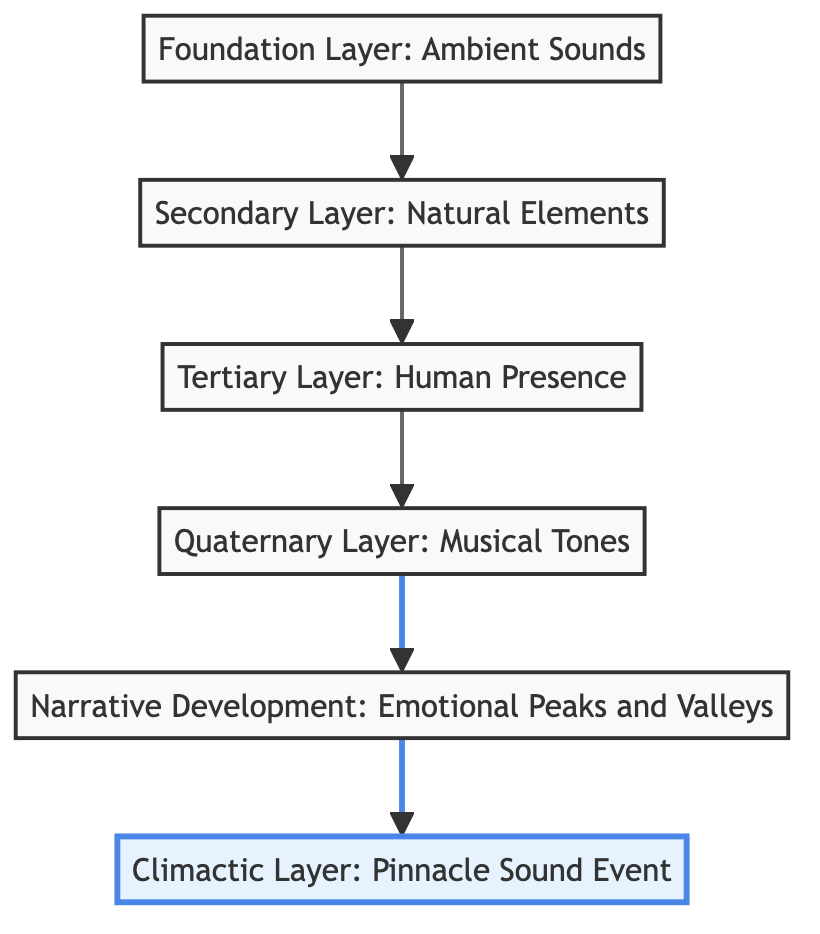What is the highest layer in the flow chart? The highest layer in the flow chart is the "Climactic Layer: Pinnacle Sound Event," which is positioned at the top and highlighted.
Answer: Climactic Layer: Pinnacle Sound Event How many layers are in the diagram? There are a total of six layers depicted in the flow chart, starting from the "Foundation Layer: Ambient Sounds" to the "Climactic Layer: Pinnacle Sound Event."
Answer: Six What comes directly before the "Narrative Development: Emotional Peaks and Valleys"? The layer that comes directly before the "Narrative Development: Emotional Peaks and Valleys" is the "Quaternary Layer: Musical Tones," which flows into the Narrative Development node.
Answer: Quaternary Layer: Musical Tones What is the role of the "Tertiary Layer: Human Presence"? The "Tertiary Layer: Human Presence" serves to introduce subtle indications of human presence to the soundscape, adding complexity and depth between the "Secondary Layer: Natural Elements" and the "Quaternary Layer: Musical Tones."
Answer: To add complexity and depth Which layer is highlighted in the diagram? The layer that is highlighted in the diagram is the "Climactic Layer: Pinnacle Sound Event," which emphasizes its importance in the overall narrative structure.
Answer: Climactic Layer: Pinnacle Sound Event What is the flow direction of the diagram? The flow direction of the diagram is from bottom to top, with each layer building upon the previous one to develop the narrative.
Answer: Bottom to top What elements are included in the foundation layer? The foundation layer includes ambient sounds such as rain, wind, or city noise, which serve as the base for the soundscape narrative.
Answer: Rain, wind, or city noise What is the main purpose of the "Quaternary Layer: Musical Tones"? The main purpose of the "Quaternary Layer: Musical Tones" is to weave in musical tones or instrumental sounds to evoke particular emotions or set a specific mood in the sound narrative.
Answer: To evoke emotions or set a mood 